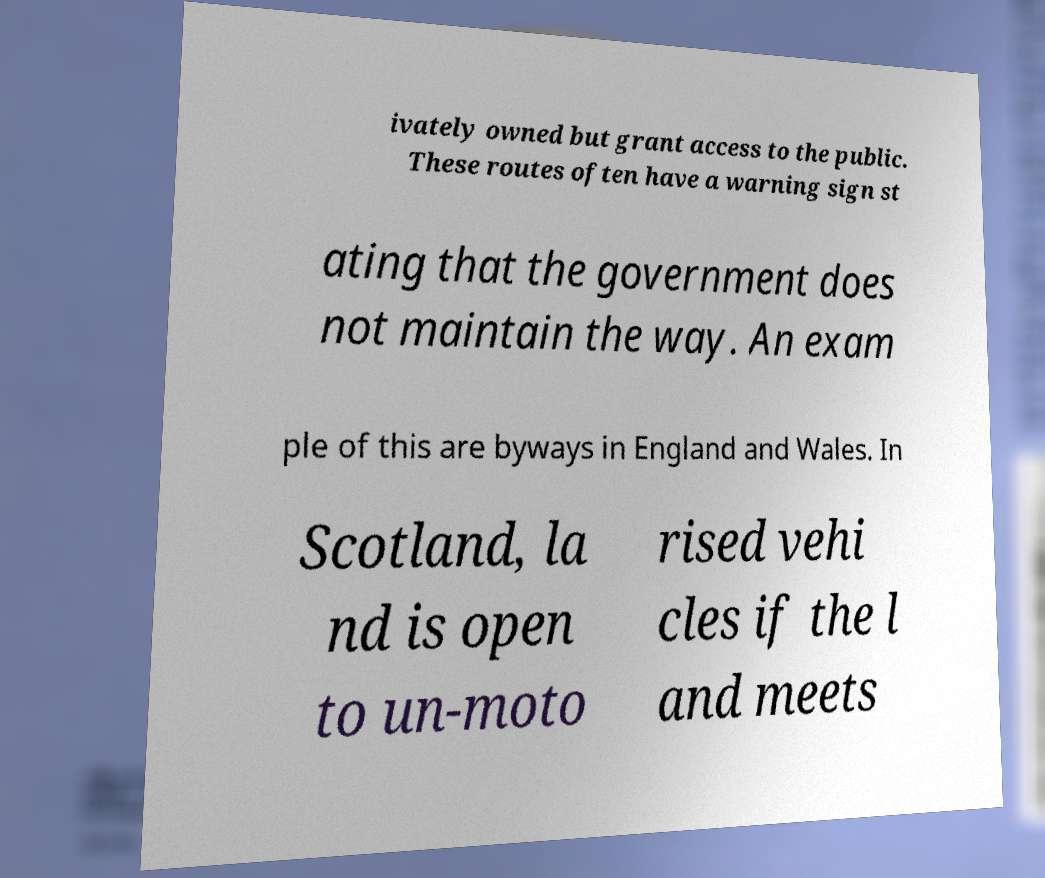Could you extract and type out the text from this image? ivately owned but grant access to the public. These routes often have a warning sign st ating that the government does not maintain the way. An exam ple of this are byways in England and Wales. In Scotland, la nd is open to un-moto rised vehi cles if the l and meets 